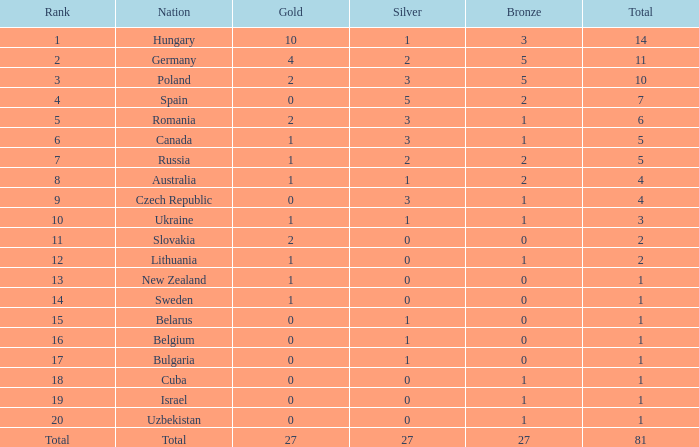How much Bronze has a Gold larger than 1, and a Silver smaller than 3, and a Nation of germany, and a Total larger than 11? 0.0. 